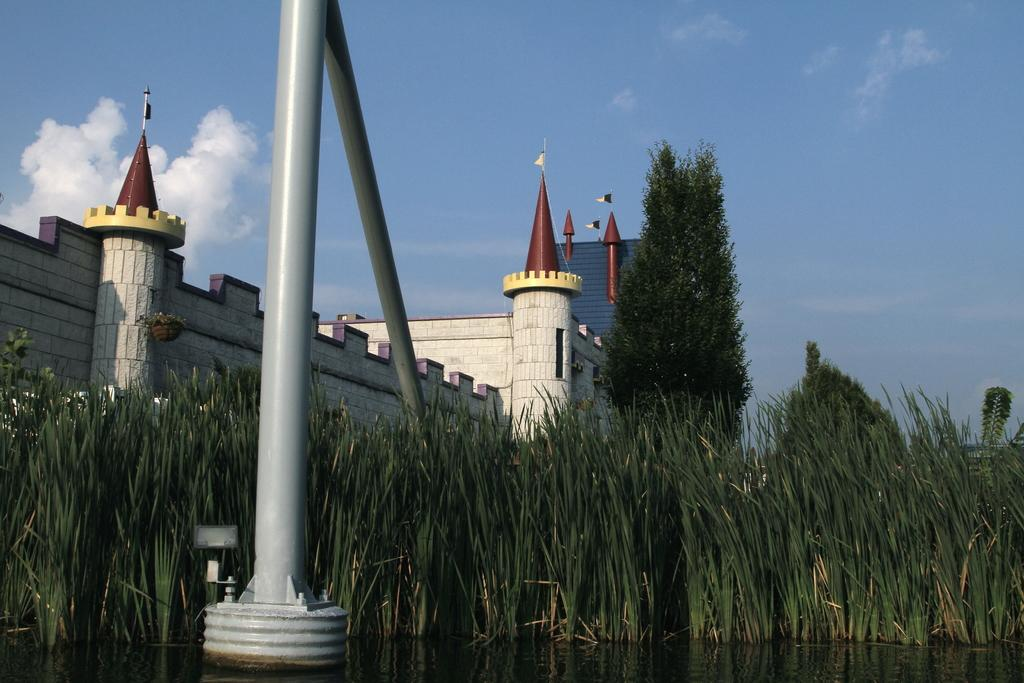Where was the image taken? The image was clicked outside. What can be seen in the middle of the image? There is a building and a tree in the middle of the image. What type of vegetation is visible at the bottom of the image? There is grass at the bottom of the image. What is visible at the top of the image? The sky is visible at the top of the image. How many kittens are playing with a copy of a book in the image? There are no kittens or books present in the image. 